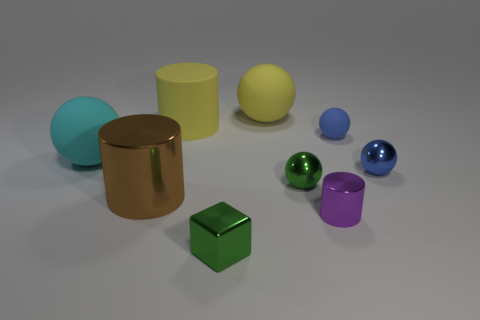The ball that is the same color as the rubber cylinder is what size?
Make the answer very short. Large. Is the number of small yellow cubes less than the number of yellow rubber things?
Your answer should be very brief. Yes. There is a metal thing that is to the left of the blue matte ball and behind the large metallic cylinder; what size is it?
Your answer should be compact. Small. What is the size of the thing that is in front of the cylinder that is right of the rubber sphere behind the blue matte ball?
Provide a short and direct response. Small. How big is the purple cylinder?
Provide a succinct answer. Small. There is a small blue object that is behind the metal sphere behind the small green shiny sphere; is there a ball that is in front of it?
Provide a short and direct response. Yes. What number of tiny objects are either purple cubes or green metallic spheres?
Your response must be concise. 1. Is there anything else of the same color as the small matte thing?
Offer a terse response. Yes. Is the size of the purple cylinder on the right side of the yellow cylinder the same as the large cyan sphere?
Offer a terse response. No. What color is the cylinder that is behind the blue ball that is left of the metallic ball that is behind the small green sphere?
Offer a very short reply. Yellow. 